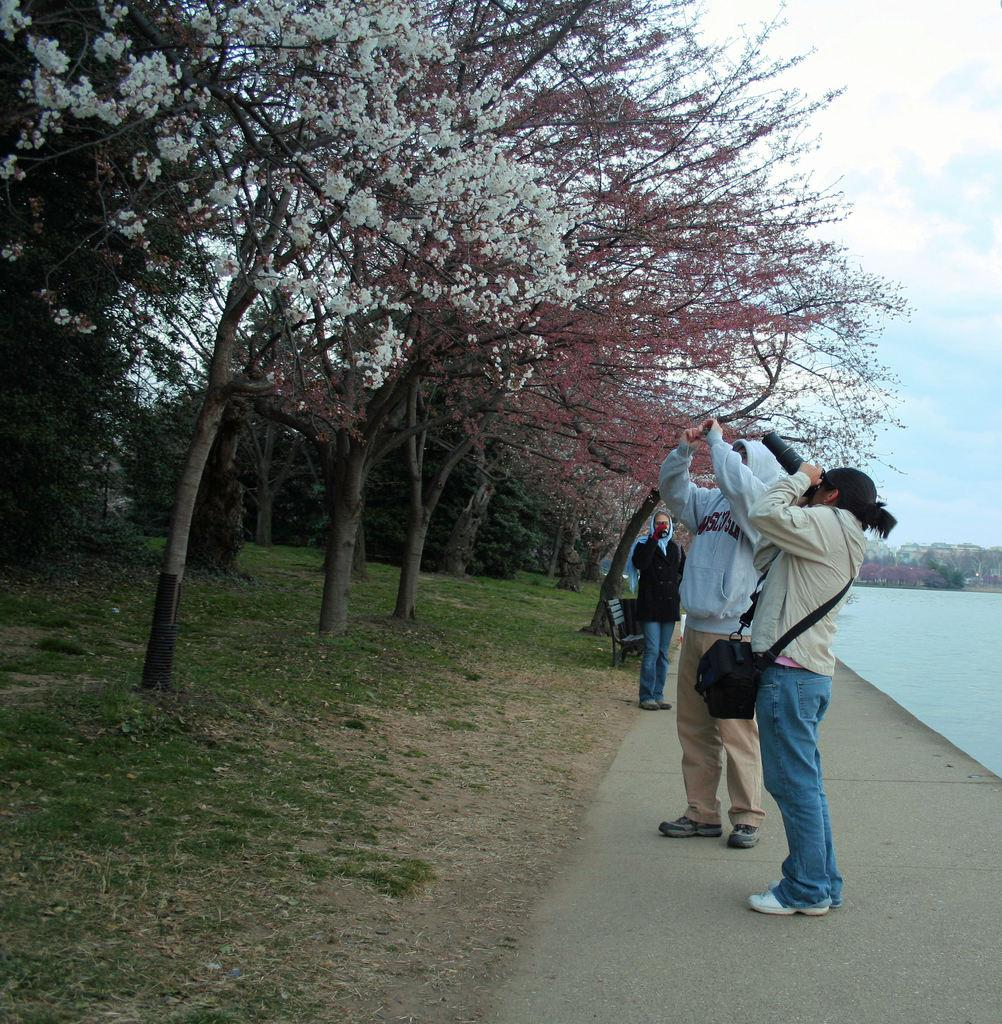How many people are standing on the path in the image? There are three men standing on a path in the image. What is one person doing in the image? One person is taking pictures. What can be seen on the right side of the image? There is a pond on the right side of the image. What type of vegetation is on the left side of the image? There are trees on the left side of the image. What type of badge is the person wearing in the image? There is no badge visible in the image. Can you hear thunder in the background of the image? There is no sound or indication of thunder in the image. 